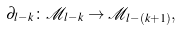Convert formula to latex. <formula><loc_0><loc_0><loc_500><loc_500>\partial _ { l - k } \colon { \mathcal { M } } _ { l - k } \to { \mathcal { M } } _ { l - ( k + 1 ) } ,</formula> 